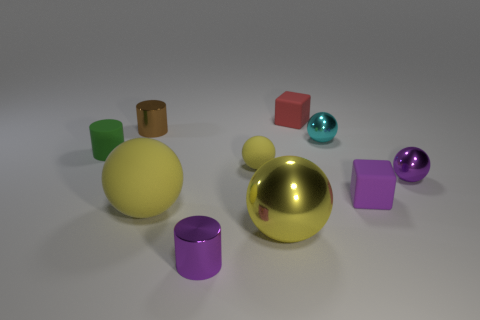Subtract all yellow spheres. How many were subtracted if there are1yellow spheres left? 2 Subtract all cyan cylinders. How many yellow spheres are left? 3 Subtract 2 spheres. How many spheres are left? 3 Subtract all purple balls. How many balls are left? 4 Subtract all small purple balls. How many balls are left? 4 Subtract all purple balls. Subtract all green cubes. How many balls are left? 4 Subtract all cylinders. How many objects are left? 7 Subtract all tiny brown things. Subtract all tiny yellow rubber things. How many objects are left? 8 Add 2 purple blocks. How many purple blocks are left? 3 Add 1 yellow things. How many yellow things exist? 4 